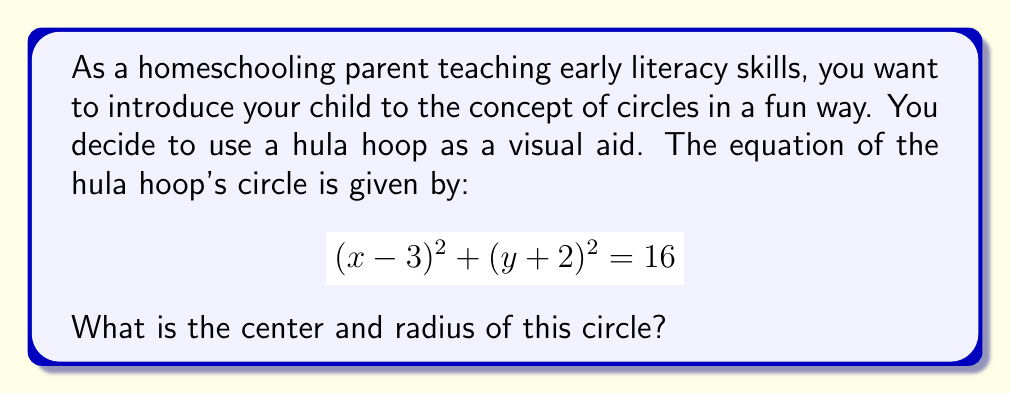Can you answer this question? Let's break this down step-by-step:

1) The general equation of a circle is:

   $$(x - h)^2 + (y - k)^2 = r^2$$

   where $(h, k)$ is the center and $r$ is the radius.

2) Comparing our equation to the general form:

   $$(x - 3)^2 + (y + 2)^2 = 16$$

3) We can see that:
   - $(x - 3)^2$ corresponds to $(x - h)^2$, so $h = 3$
   - $(y + 2)^2$ corresponds to $(y - k)^2$, so $-k = 2$ or $k = -2$
   - The right side, 16, corresponds to $r^2$

4) Therefore, the center is $(3, -2)$

5) For the radius, we need to take the square root of 16:

   $$r = \sqrt{16} = 4$$

As a teaching aid, you can place the hula hoop on a coordinate grid on the floor, with its center at (3, -2) and explain that the distance from the center to any point on the hula hoop is always 4 units.
Answer: The center of the circle is $(3, -2)$ and the radius is 4. 